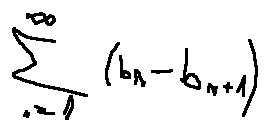<formula> <loc_0><loc_0><loc_500><loc_500>\sum \lim i t s _ { n = 1 } ^ { \infty } ( b _ { n } - b _ { n + 1 } )</formula> 